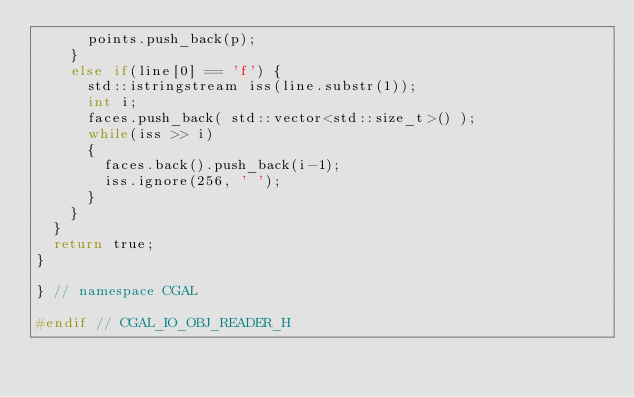Convert code to text. <code><loc_0><loc_0><loc_500><loc_500><_C_>      points.push_back(p);
    }
    else if(line[0] == 'f') {
      std::istringstream iss(line.substr(1));
      int i;
      faces.push_back( std::vector<std::size_t>() );
      while(iss >> i)
      {
        faces.back().push_back(i-1);
        iss.ignore(256, ' ');
      }
    }
  }
  return true;
}

} // namespace CGAL

#endif // CGAL_IO_OBJ_READER_H
</code> 